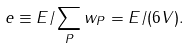<formula> <loc_0><loc_0><loc_500><loc_500>e \equiv E / \sum _ { P } w _ { P } = E / ( 6 V ) .</formula> 